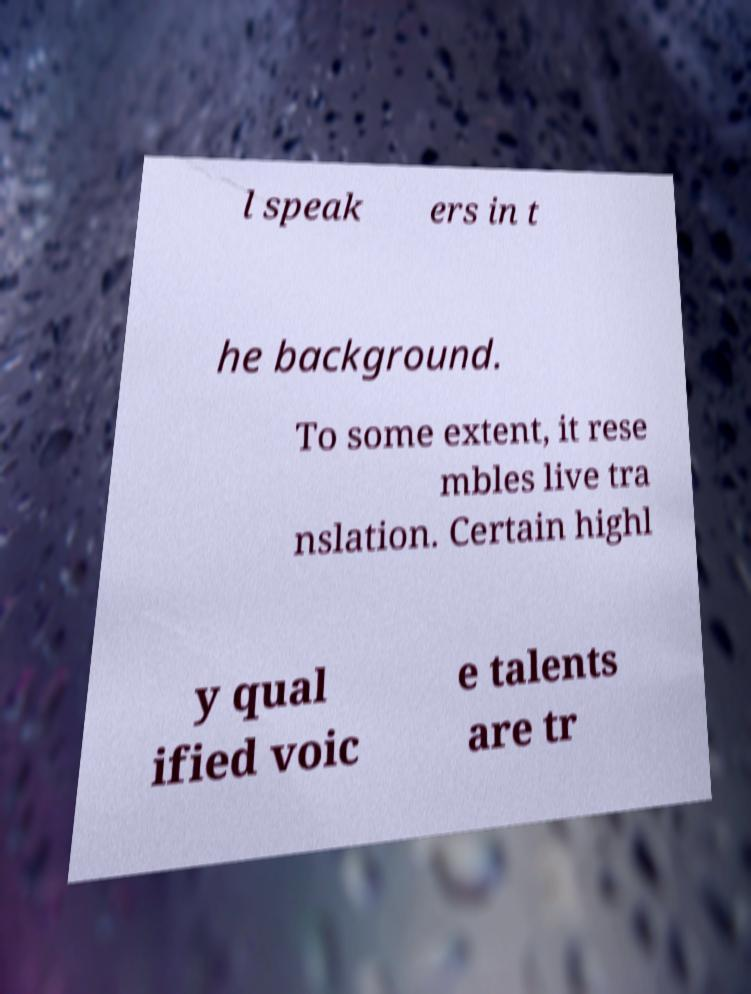For documentation purposes, I need the text within this image transcribed. Could you provide that? l speak ers in t he background. To some extent, it rese mbles live tra nslation. Certain highl y qual ified voic e talents are tr 